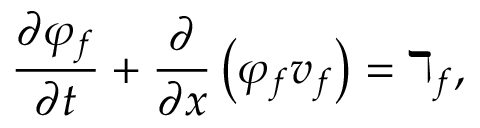<formula> <loc_0><loc_0><loc_500><loc_500>\frac { \partial \varphi _ { f } } { \partial t } + \frac { \partial } { \partial x } \left ( \varphi _ { f } v _ { f } \right ) = \daleth _ { f } ,</formula> 